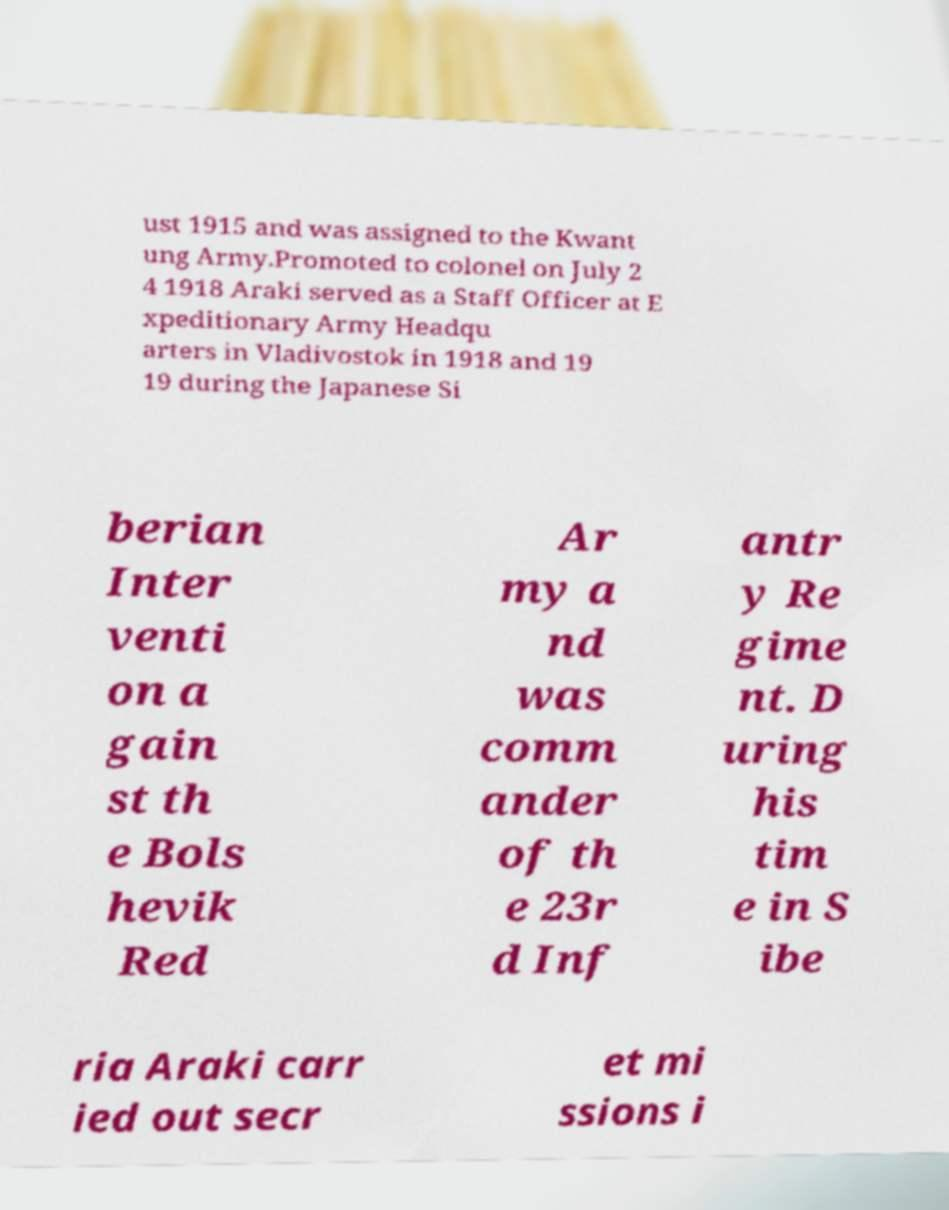Please identify and transcribe the text found in this image. ust 1915 and was assigned to the Kwant ung Army.Promoted to colonel on July 2 4 1918 Araki served as a Staff Officer at E xpeditionary Army Headqu arters in Vladivostok in 1918 and 19 19 during the Japanese Si berian Inter venti on a gain st th e Bols hevik Red Ar my a nd was comm ander of th e 23r d Inf antr y Re gime nt. D uring his tim e in S ibe ria Araki carr ied out secr et mi ssions i 